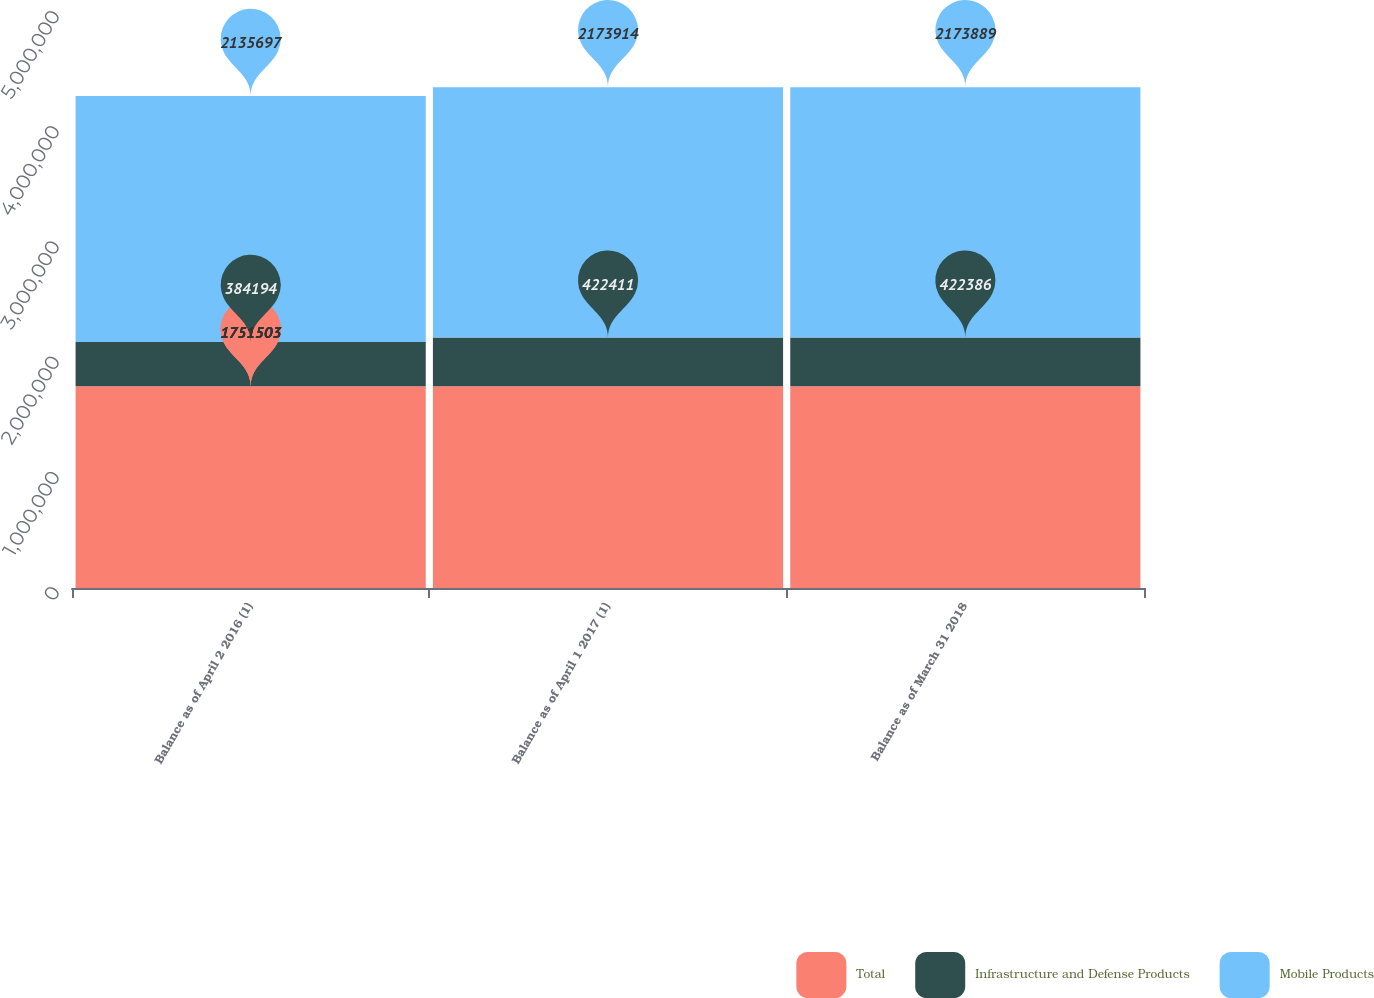Convert chart. <chart><loc_0><loc_0><loc_500><loc_500><stacked_bar_chart><ecel><fcel>Balance as of April 2 2016 (1)<fcel>Balance as of April 1 2017 (1)<fcel>Balance as of March 31 2018<nl><fcel>Total<fcel>1.7515e+06<fcel>1.7515e+06<fcel>1.7515e+06<nl><fcel>Infrastructure and Defense Products<fcel>384194<fcel>422411<fcel>422386<nl><fcel>Mobile Products<fcel>2.1357e+06<fcel>2.17391e+06<fcel>2.17389e+06<nl></chart> 